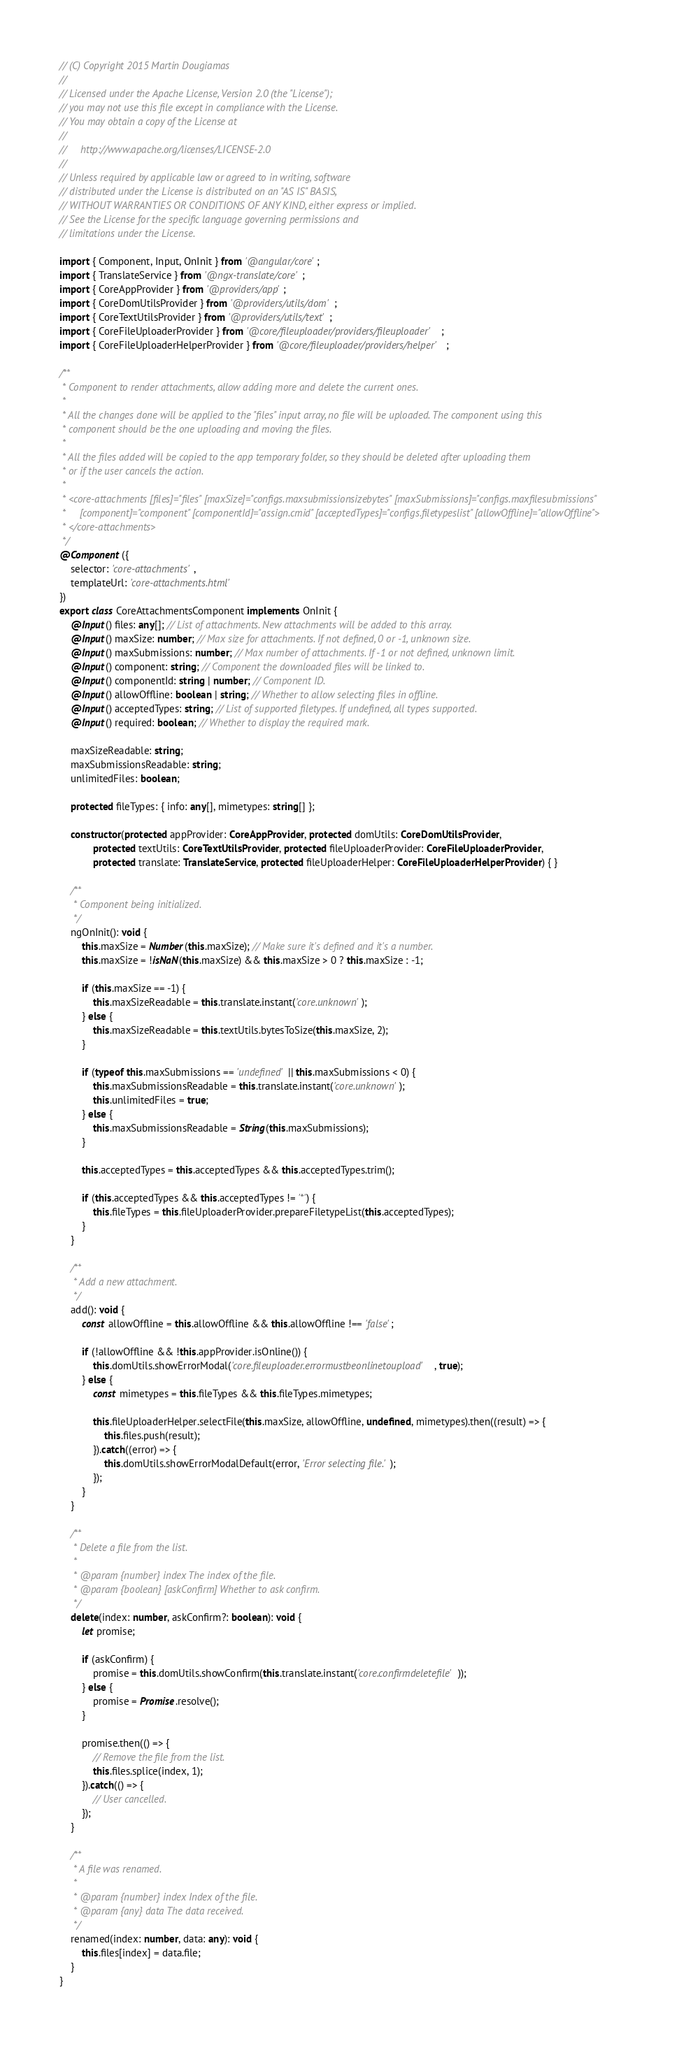Convert code to text. <code><loc_0><loc_0><loc_500><loc_500><_TypeScript_>// (C) Copyright 2015 Martin Dougiamas
//
// Licensed under the Apache License, Version 2.0 (the "License");
// you may not use this file except in compliance with the License.
// You may obtain a copy of the License at
//
//     http://www.apache.org/licenses/LICENSE-2.0
//
// Unless required by applicable law or agreed to in writing, software
// distributed under the License is distributed on an "AS IS" BASIS,
// WITHOUT WARRANTIES OR CONDITIONS OF ANY KIND, either express or implied.
// See the License for the specific language governing permissions and
// limitations under the License.

import { Component, Input, OnInit } from '@angular/core';
import { TranslateService } from '@ngx-translate/core';
import { CoreAppProvider } from '@providers/app';
import { CoreDomUtilsProvider } from '@providers/utils/dom';
import { CoreTextUtilsProvider } from '@providers/utils/text';
import { CoreFileUploaderProvider } from '@core/fileuploader/providers/fileuploader';
import { CoreFileUploaderHelperProvider } from '@core/fileuploader/providers/helper';

/**
 * Component to render attachments, allow adding more and delete the current ones.
 *
 * All the changes done will be applied to the "files" input array, no file will be uploaded. The component using this
 * component should be the one uploading and moving the files.
 *
 * All the files added will be copied to the app temporary folder, so they should be deleted after uploading them
 * or if the user cancels the action.
 *
 * <core-attachments [files]="files" [maxSize]="configs.maxsubmissionsizebytes" [maxSubmissions]="configs.maxfilesubmissions"
 *     [component]="component" [componentId]="assign.cmid" [acceptedTypes]="configs.filetypeslist" [allowOffline]="allowOffline">
 * </core-attachments>
 */
@Component({
    selector: 'core-attachments',
    templateUrl: 'core-attachments.html'
})
export class CoreAttachmentsComponent implements OnInit {
    @Input() files: any[]; // List of attachments. New attachments will be added to this array.
    @Input() maxSize: number; // Max size for attachments. If not defined, 0 or -1, unknown size.
    @Input() maxSubmissions: number; // Max number of attachments. If -1 or not defined, unknown limit.
    @Input() component: string; // Component the downloaded files will be linked to.
    @Input() componentId: string | number; // Component ID.
    @Input() allowOffline: boolean | string; // Whether to allow selecting files in offline.
    @Input() acceptedTypes: string; // List of supported filetypes. If undefined, all types supported.
    @Input() required: boolean; // Whether to display the required mark.

    maxSizeReadable: string;
    maxSubmissionsReadable: string;
    unlimitedFiles: boolean;

    protected fileTypes: { info: any[], mimetypes: string[] };

    constructor(protected appProvider: CoreAppProvider, protected domUtils: CoreDomUtilsProvider,
            protected textUtils: CoreTextUtilsProvider, protected fileUploaderProvider: CoreFileUploaderProvider,
            protected translate: TranslateService, protected fileUploaderHelper: CoreFileUploaderHelperProvider) { }

    /**
     * Component being initialized.
     */
    ngOnInit(): void {
        this.maxSize = Number(this.maxSize); // Make sure it's defined and it's a number.
        this.maxSize = !isNaN(this.maxSize) && this.maxSize > 0 ? this.maxSize : -1;

        if (this.maxSize == -1) {
            this.maxSizeReadable = this.translate.instant('core.unknown');
        } else {
            this.maxSizeReadable = this.textUtils.bytesToSize(this.maxSize, 2);
        }

        if (typeof this.maxSubmissions == 'undefined' || this.maxSubmissions < 0) {
            this.maxSubmissionsReadable = this.translate.instant('core.unknown');
            this.unlimitedFiles = true;
        } else {
            this.maxSubmissionsReadable = String(this.maxSubmissions);
        }

        this.acceptedTypes = this.acceptedTypes && this.acceptedTypes.trim();

        if (this.acceptedTypes && this.acceptedTypes != '*') {
            this.fileTypes = this.fileUploaderProvider.prepareFiletypeList(this.acceptedTypes);
        }
    }

    /**
     * Add a new attachment.
     */
    add(): void {
        const allowOffline = this.allowOffline && this.allowOffline !== 'false';

        if (!allowOffline && !this.appProvider.isOnline()) {
            this.domUtils.showErrorModal('core.fileuploader.errormustbeonlinetoupload', true);
        } else {
            const mimetypes = this.fileTypes && this.fileTypes.mimetypes;

            this.fileUploaderHelper.selectFile(this.maxSize, allowOffline, undefined, mimetypes).then((result) => {
                this.files.push(result);
            }).catch((error) => {
                this.domUtils.showErrorModalDefault(error, 'Error selecting file.');
            });
        }
    }

    /**
     * Delete a file from the list.
     *
     * @param {number} index The index of the file.
     * @param {boolean} [askConfirm] Whether to ask confirm.
     */
    delete(index: number, askConfirm?: boolean): void {
        let promise;

        if (askConfirm) {
            promise = this.domUtils.showConfirm(this.translate.instant('core.confirmdeletefile'));
        } else {
            promise = Promise.resolve();
        }

        promise.then(() => {
            // Remove the file from the list.
            this.files.splice(index, 1);
        }).catch(() => {
            // User cancelled.
        });
    }

    /**
     * A file was renamed.
     *
     * @param {number} index Index of the file.
     * @param {any} data The data received.
     */
    renamed(index: number, data: any): void {
        this.files[index] = data.file;
    }
}
</code> 